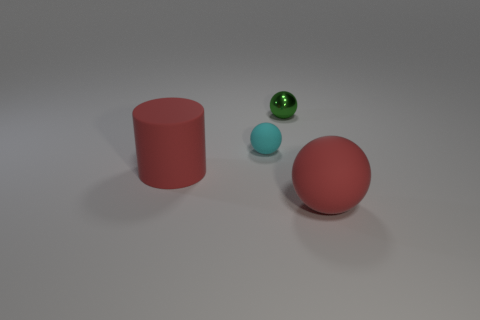What number of tiny objects are the same color as the large rubber sphere?
Keep it short and to the point. 0. Does the small cyan thing have the same shape as the tiny metallic thing?
Your answer should be compact. Yes. There is a red thing in front of the red matte thing that is left of the cyan object; what is its size?
Your response must be concise. Large. Are there any gray balls of the same size as the rubber cylinder?
Give a very brief answer. No. There is a rubber sphere that is left of the tiny shiny object; is it the same size as the green metallic object that is behind the tiny cyan matte ball?
Give a very brief answer. Yes. There is a red rubber object that is behind the large matte sphere in front of the large red cylinder; what shape is it?
Provide a succinct answer. Cylinder. What number of red matte objects are in front of the big rubber cylinder?
Give a very brief answer. 1. What is the color of the tiny sphere that is the same material as the red cylinder?
Your answer should be compact. Cyan. Is the size of the green object the same as the rubber sphere left of the small green thing?
Offer a terse response. Yes. There is a red matte thing that is right of the large red rubber object on the left side of the thing that is behind the small matte thing; how big is it?
Offer a very short reply. Large. 